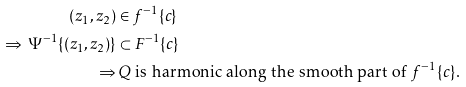Convert formula to latex. <formula><loc_0><loc_0><loc_500><loc_500>( z _ { 1 } , z _ { 2 } ) & \in f ^ { - 1 } \{ c \} \\ \Rightarrow \, \Psi ^ { - 1 } \{ ( z _ { 1 } , z _ { 2 } ) \} & \subset F ^ { - 1 } \{ c \} \\ \Rightarrow & \, \text {$Q$ is harmonic along the smooth part of $f^{-1}\{c\}$.}</formula> 